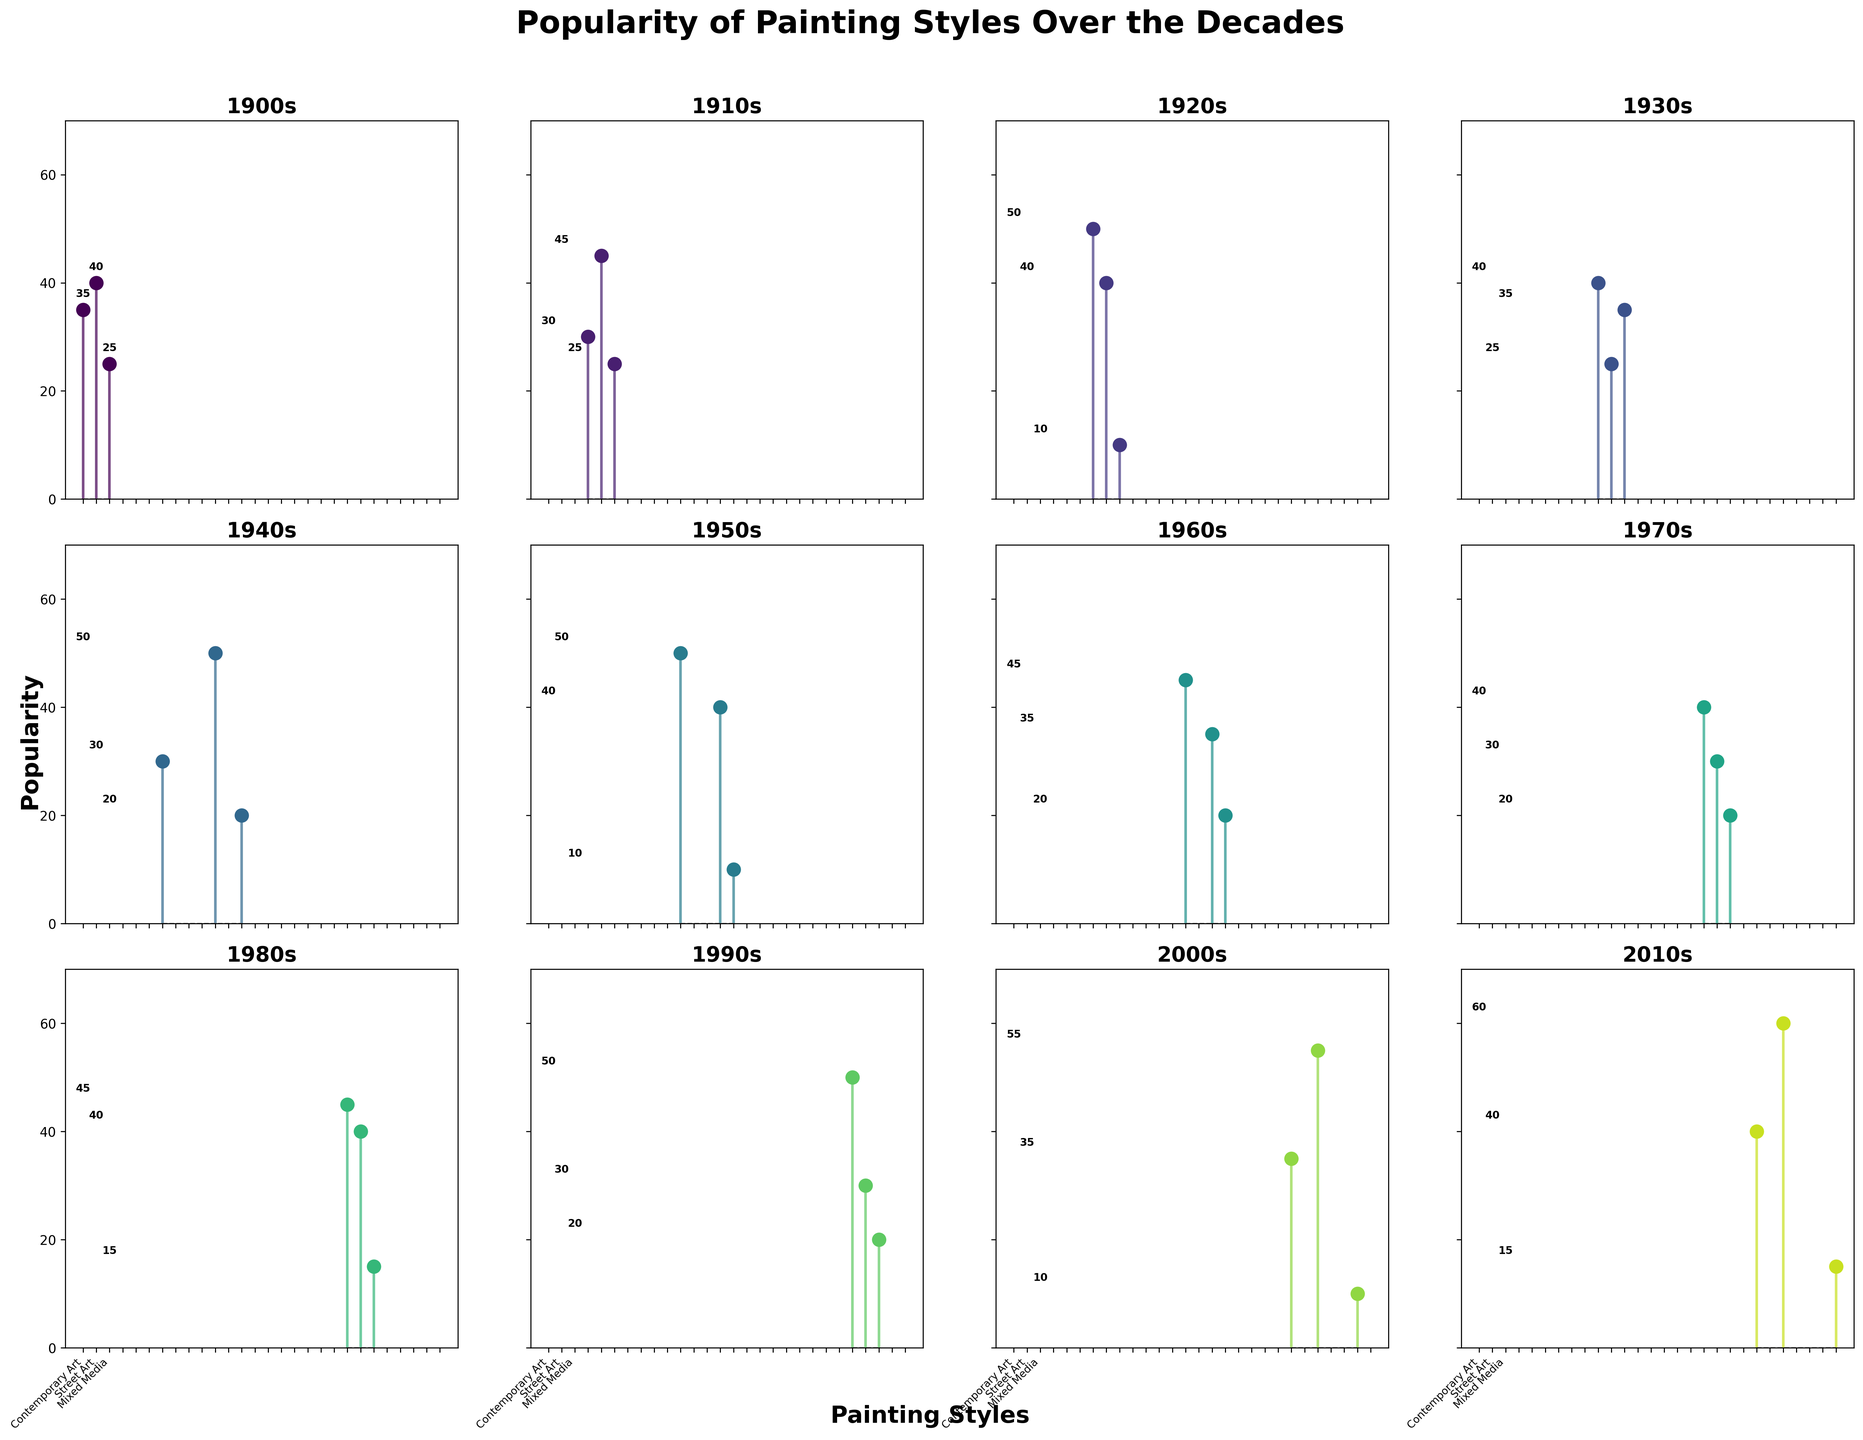Which decade had the highest popularity for Contemporary Art? To find the decade with the highest popularity for Contemporary Art, look at the stem plots corresponding to each decade and compare the values. The highest value for Contemporary Art is 60 in the 2010s.
Answer: 2010s What was the popularity of Post-Impressionism in the 1900s? Find the stem plot for the 1900s and locate the marker for Post-Impressionism. The value next to it indicates the popularity which is 40.
Answer: 40 Which painting style had a 50 popularity score in the 1940s? Check the stem plot for the 1940s and see which painting style corresponds to the 50 popularity score. It is Abstract Expressionism.
Answer: Abstract Expressionism How did the popularity of Surrealism change from the 1940s to the 2010s? Compare the stem plots for the 1940s and the 2010s for the Surrealism painting style. In the 1940s, the popularity was 30, while in the 2010s, it is not listed, meaning its popularity dropped to zero or was negligible.
Answer: Decreased In which decade was Street Art most popular? Observe the stem plots and identify the decade with the highest marker for Street Art. The highest value for Street Art is 40 in the 2010s.
Answer: 2010s Which decade had the most diversity in painting styles? Count the number of different painting styles listed for each decade. The 1920s, 1930s, and 1970s each have three styles listed, making them the decades with the most diversity.
Answer: 1920s, 1930s, 1970s Did any painting style maintain a popularity of 50 across multiple decades? Scan through each stem plot to identify any style marked with a 50 in more than one decade. Abstract Expressionism has a popularity of 50 in both the 1940s and 1950s.
Answer: Abstract Expressionism What is the average popularity of different painting styles in the 1920s? Sum the popularity scores for all painting styles in the 1920s and divide by the number of styles. The scores are 50 for Surrealism, 40 for Art Deco, and 10 for Precisionism. The sum is 100. There are 3 styles, so the average is 100/3 ≈ 33.33.
Answer: 33.33 